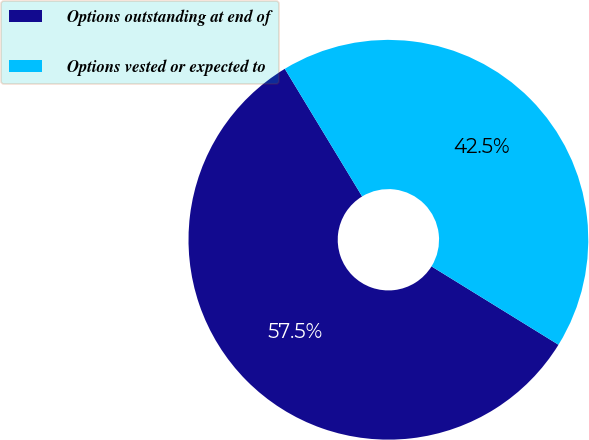<chart> <loc_0><loc_0><loc_500><loc_500><pie_chart><fcel>Options outstanding at end of<fcel>Options vested or expected to<nl><fcel>57.53%<fcel>42.47%<nl></chart> 